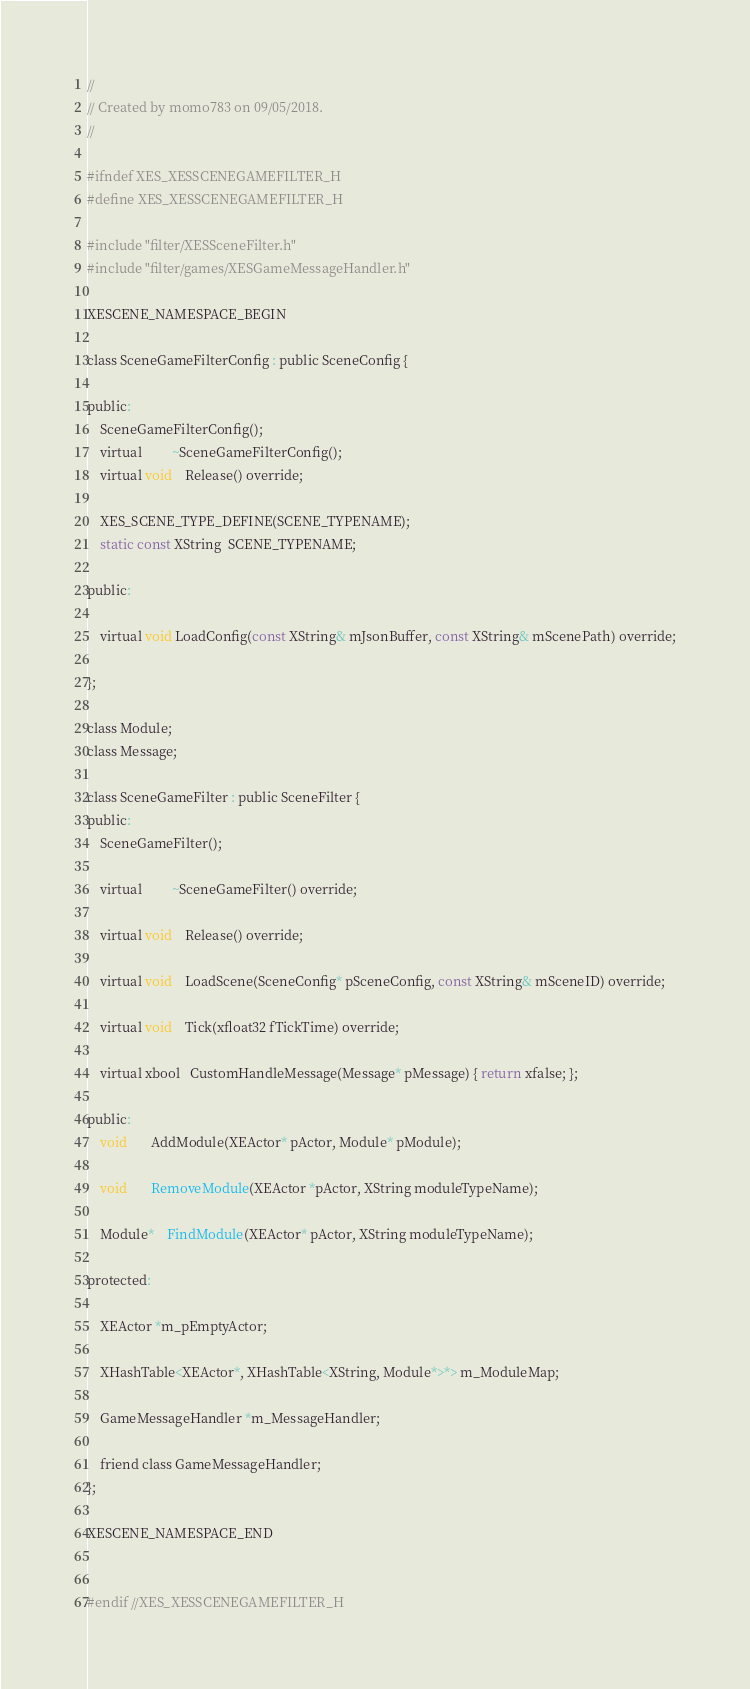<code> <loc_0><loc_0><loc_500><loc_500><_C_>//
// Created by momo783 on 09/05/2018.
//

#ifndef XES_XESSCENEGAMEFILTER_H
#define XES_XESSCENEGAMEFILTER_H

#include "filter/XESSceneFilter.h"
#include "filter/games/XESGameMessageHandler.h"

XESCENE_NAMESPACE_BEGIN

class SceneGameFilterConfig : public SceneConfig {

public:
    SceneGameFilterConfig();
    virtual         ~SceneGameFilterConfig();
    virtual void    Release() override;
    
    XES_SCENE_TYPE_DEFINE(SCENE_TYPENAME);
    static const XString  SCENE_TYPENAME;

public:

    virtual void LoadConfig(const XString& mJsonBuffer, const XString& mScenePath) override;

};

class Module;
class Message;

class SceneGameFilter : public SceneFilter {
public:
    SceneGameFilter();

    virtual         ~SceneGameFilter() override;

    virtual void    Release() override;

    virtual void    LoadScene(SceneConfig* pSceneConfig, const XString& mSceneID) override;

    virtual void    Tick(xfloat32 fTickTime) override;

    virtual xbool   CustomHandleMessage(Message* pMessage) { return xfalse; };

public:
    void       AddModule(XEActor* pActor, Module* pModule);

    void       RemoveModule(XEActor *pActor, XString moduleTypeName);

    Module*    FindModule(XEActor* pActor, XString moduleTypeName);

protected:

    XEActor *m_pEmptyActor;

    XHashTable<XEActor*, XHashTable<XString, Module*>*> m_ModuleMap;

    GameMessageHandler *m_MessageHandler;

    friend class GameMessageHandler;
};

XESCENE_NAMESPACE_END


#endif //XES_XESSCENEGAMEFILTER_H
</code> 